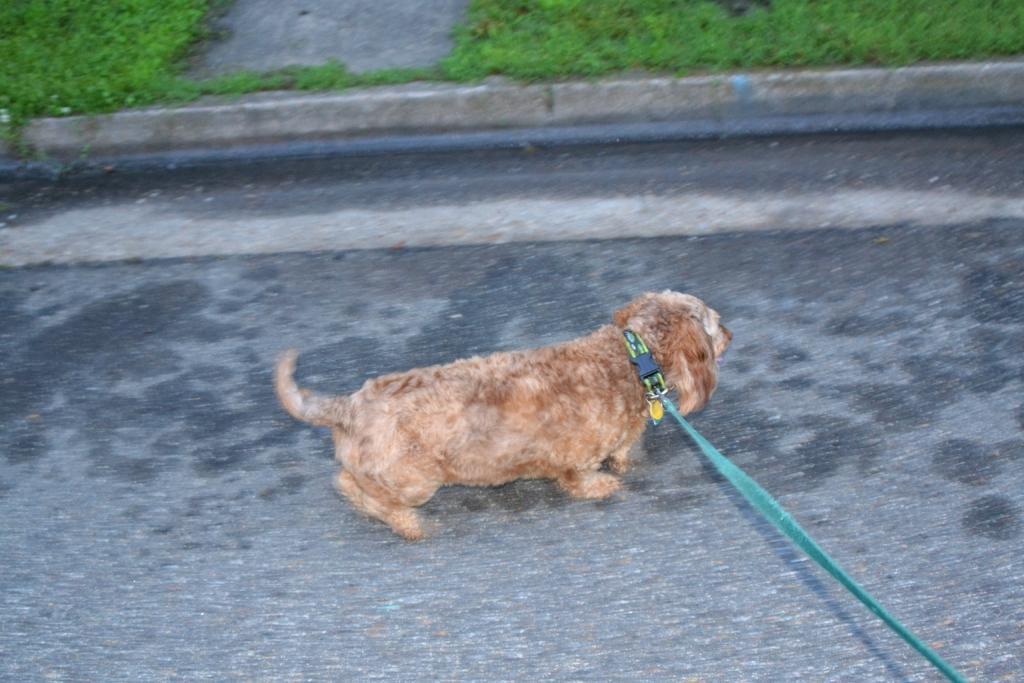Could you give a brief overview of what you see in this image? In this image I can see a dog running on the floor and I can see grass at the top. 